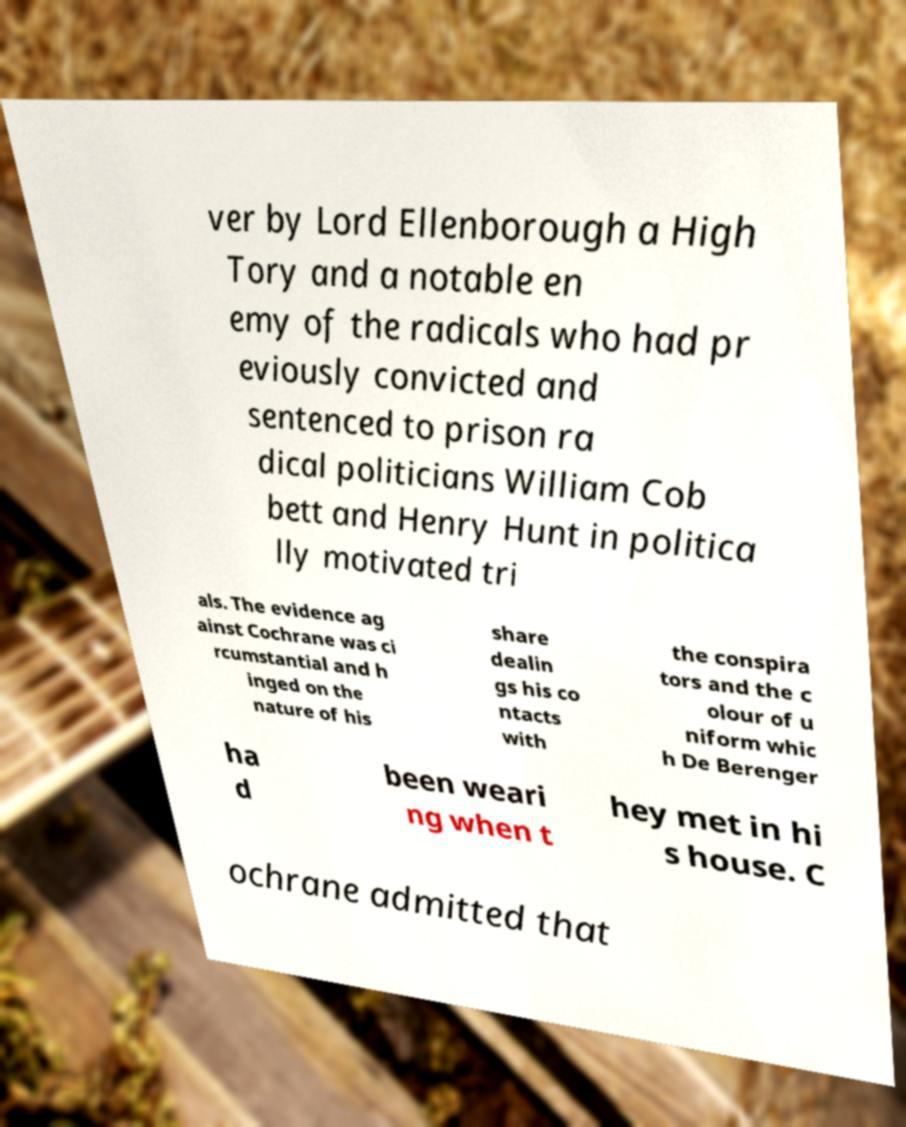There's text embedded in this image that I need extracted. Can you transcribe it verbatim? ver by Lord Ellenborough a High Tory and a notable en emy of the radicals who had pr eviously convicted and sentenced to prison ra dical politicians William Cob bett and Henry Hunt in politica lly motivated tri als. The evidence ag ainst Cochrane was ci rcumstantial and h inged on the nature of his share dealin gs his co ntacts with the conspira tors and the c olour of u niform whic h De Berenger ha d been weari ng when t hey met in hi s house. C ochrane admitted that 